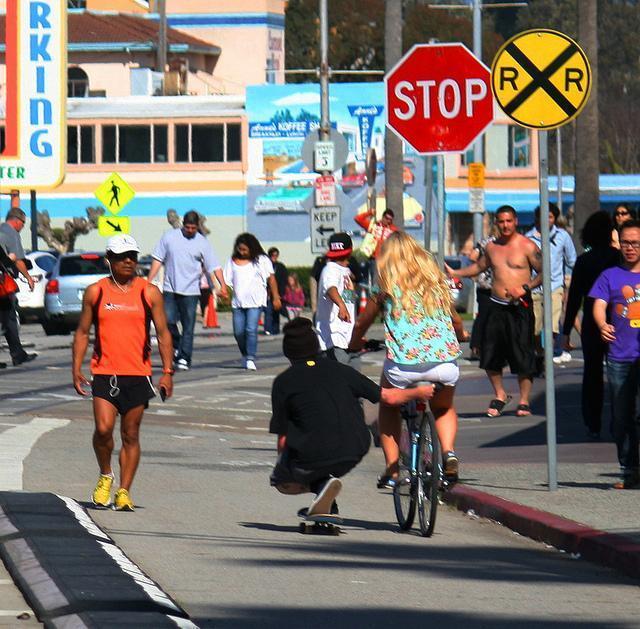How many different kinds of things with wheels are shown?
Give a very brief answer. 3. How many bicycles are visible?
Give a very brief answer. 1. How many people are visible?
Give a very brief answer. 11. 